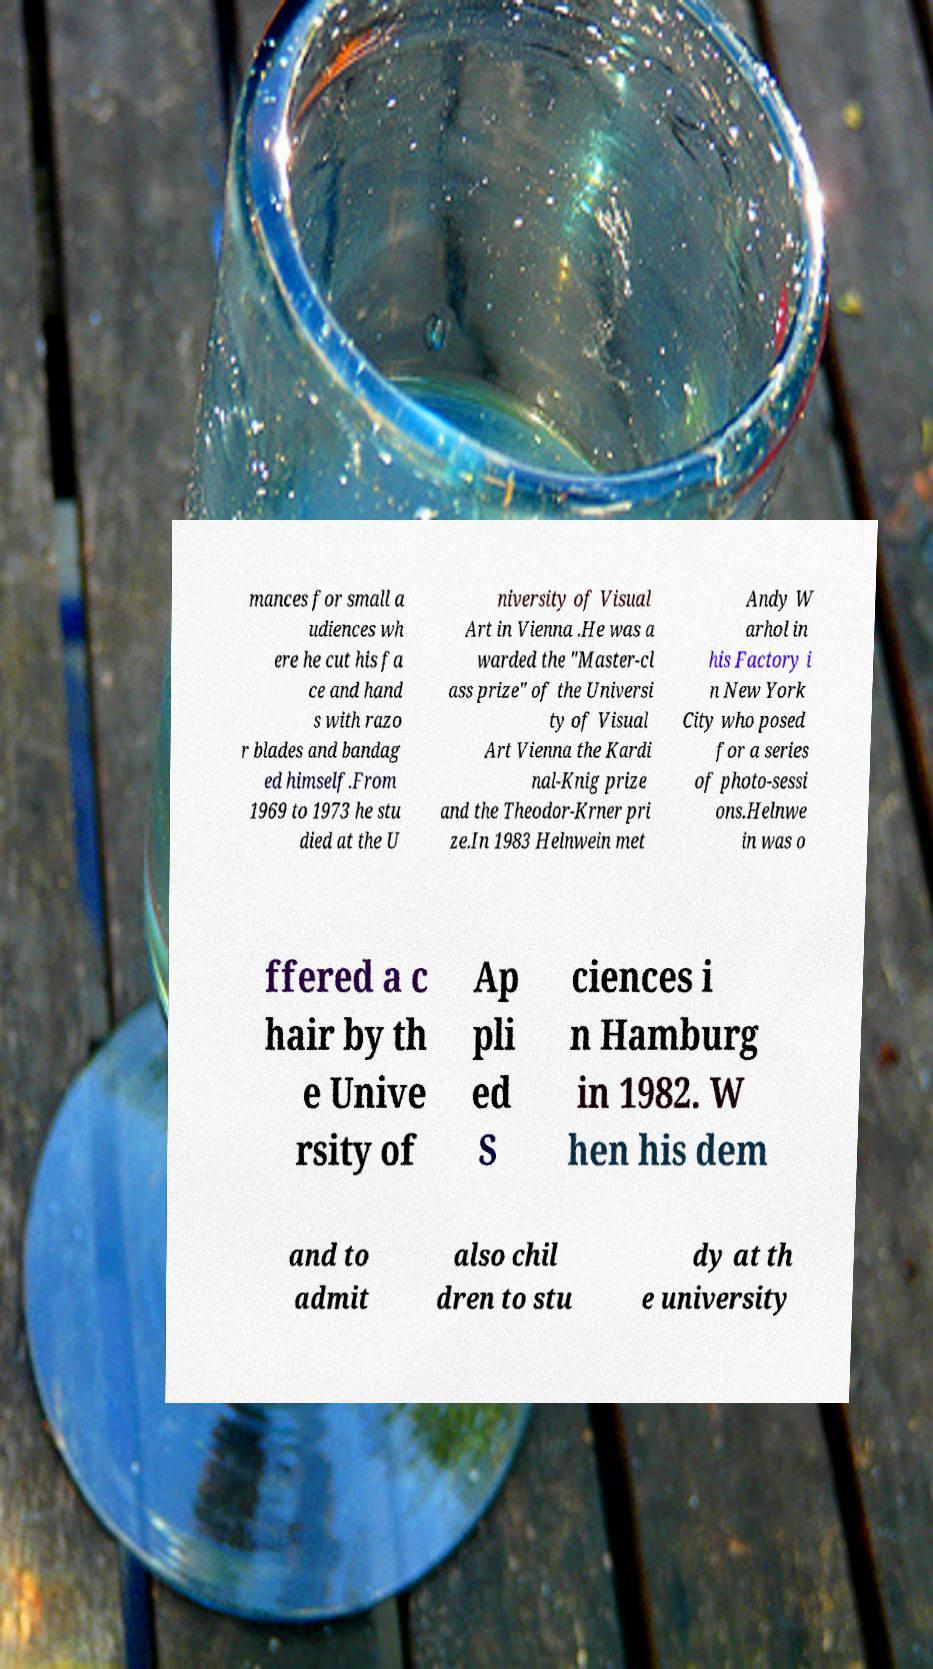Can you read and provide the text displayed in the image?This photo seems to have some interesting text. Can you extract and type it out for me? mances for small a udiences wh ere he cut his fa ce and hand s with razo r blades and bandag ed himself.From 1969 to 1973 he stu died at the U niversity of Visual Art in Vienna .He was a warded the "Master-cl ass prize" of the Universi ty of Visual Art Vienna the Kardi nal-Knig prize and the Theodor-Krner pri ze.In 1983 Helnwein met Andy W arhol in his Factory i n New York City who posed for a series of photo-sessi ons.Helnwe in was o ffered a c hair by th e Unive rsity of Ap pli ed S ciences i n Hamburg in 1982. W hen his dem and to admit also chil dren to stu dy at th e university 